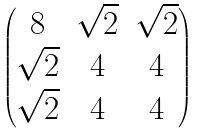Convert formula to latex. <formula><loc_0><loc_0><loc_500><loc_500>\begin{pmatrix} 8 & \sqrt { 2 } & \sqrt { 2 } \\ \sqrt { 2 } & 4 & 4 \\ \sqrt { 2 } & 4 & 4 \end{pmatrix}</formula> 